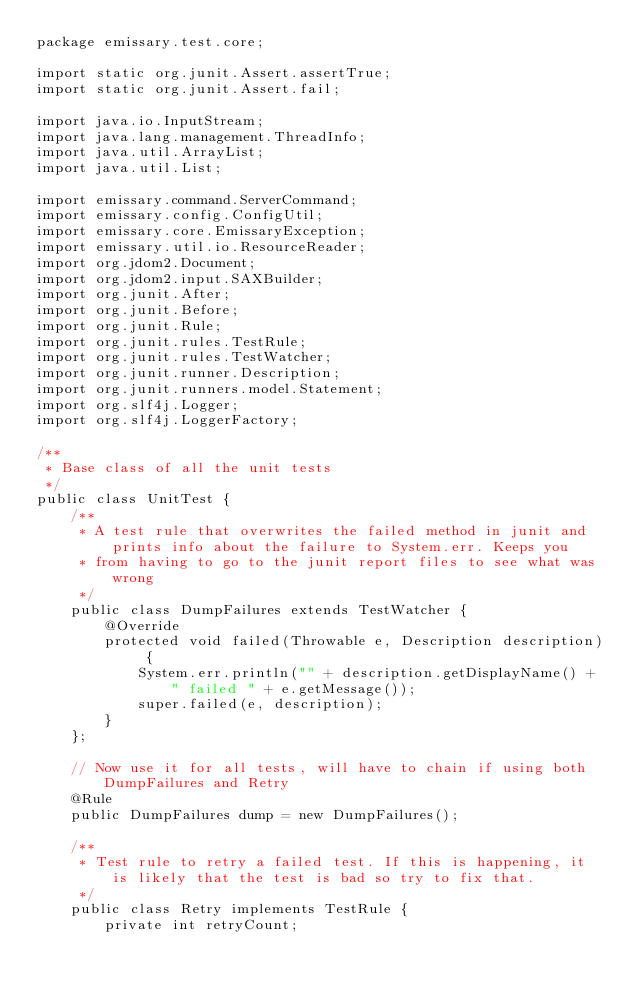Convert code to text. <code><loc_0><loc_0><loc_500><loc_500><_Java_>package emissary.test.core;

import static org.junit.Assert.assertTrue;
import static org.junit.Assert.fail;

import java.io.InputStream;
import java.lang.management.ThreadInfo;
import java.util.ArrayList;
import java.util.List;

import emissary.command.ServerCommand;
import emissary.config.ConfigUtil;
import emissary.core.EmissaryException;
import emissary.util.io.ResourceReader;
import org.jdom2.Document;
import org.jdom2.input.SAXBuilder;
import org.junit.After;
import org.junit.Before;
import org.junit.Rule;
import org.junit.rules.TestRule;
import org.junit.rules.TestWatcher;
import org.junit.runner.Description;
import org.junit.runners.model.Statement;
import org.slf4j.Logger;
import org.slf4j.LoggerFactory;

/**
 * Base class of all the unit tests
 */
public class UnitTest {
    /**
     * A test rule that overwrites the failed method in junit and prints info about the failure to System.err. Keeps you
     * from having to go to the junit report files to see what was wrong
     */
    public class DumpFailures extends TestWatcher {
        @Override
        protected void failed(Throwable e, Description description) {
            System.err.println("" + description.getDisplayName() + " failed " + e.getMessage());
            super.failed(e, description);
        }
    };

    // Now use it for all tests, will have to chain if using both DumpFailures and Retry
    @Rule
    public DumpFailures dump = new DumpFailures();

    /**
     * Test rule to retry a failed test. If this is happening, it is likely that the test is bad so try to fix that.
     */
    public class Retry implements TestRule {
        private int retryCount;
</code> 